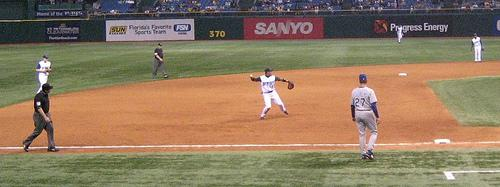Question: who is in the picture?
Choices:
A. Eight women.
B. Nine boys.
C. Four girls.
D. Seven men.
Answer with the letter. Answer: D Question: where is this picture taken?
Choices:
A. On a football field.
B. On a basketball court.
C. On a soccer field.
D. On a baseball field.
Answer with the letter. Answer: D Question: what color are the uniforms?
Choices:
A. Black.
B. Blue.
C. Red.
D. White.
Answer with the letter. Answer: D Question: how is the weather?
Choices:
A. It is rainy.
B. It is cloudy.
C. It is hazy.
D. It is clear.
Answer with the letter. Answer: D Question: why are these men on a field?
Choices:
A. They are playing soccer.
B. They are playing lacrosse.
C. They are playing baseball.
D. They are playing football.
Answer with the letter. Answer: C 